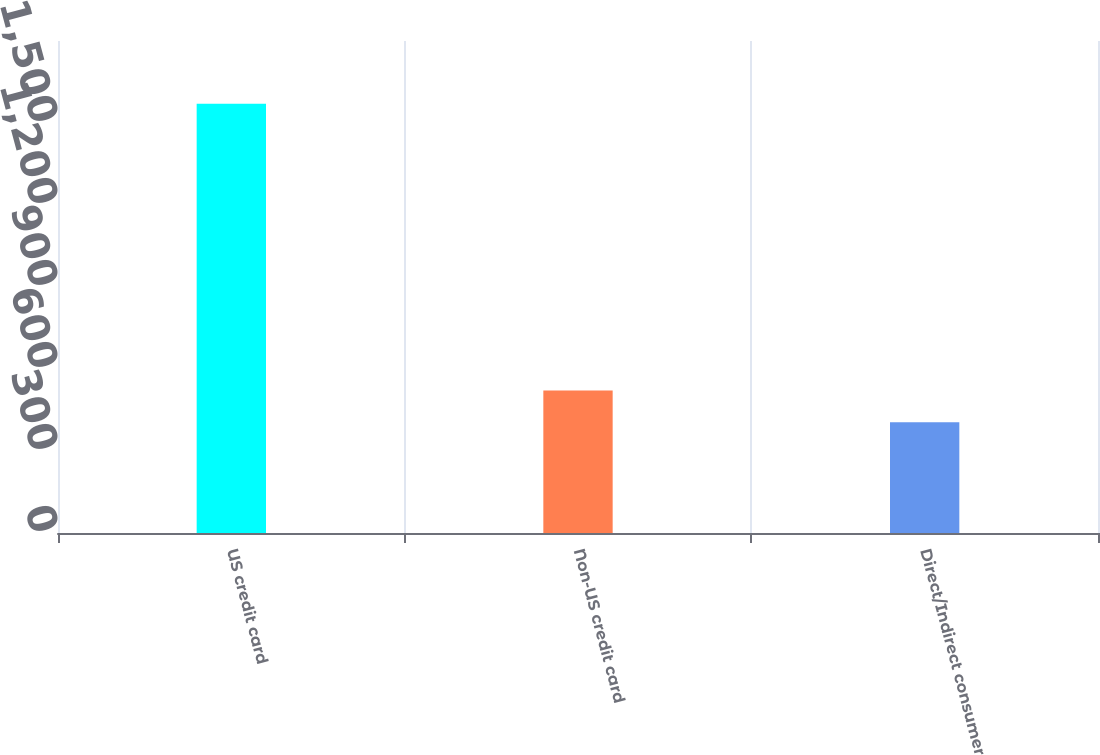Convert chart to OTSL. <chart><loc_0><loc_0><loc_500><loc_500><bar_chart><fcel>US credit card<fcel>Non-US credit card<fcel>Direct/Indirect consumer<nl><fcel>1570<fcel>521.5<fcel>405<nl></chart> 